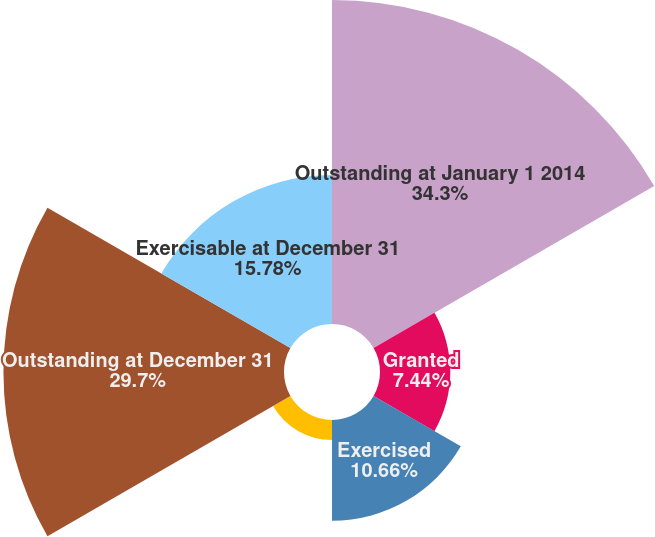Convert chart to OTSL. <chart><loc_0><loc_0><loc_500><loc_500><pie_chart><fcel>Outstanding at January 1 2014<fcel>Granted<fcel>Exercised<fcel>Forfeited or expired<fcel>Outstanding at December 31<fcel>Exercisable at December 31<nl><fcel>34.3%<fcel>7.44%<fcel>10.66%<fcel>2.12%<fcel>29.7%<fcel>15.78%<nl></chart> 